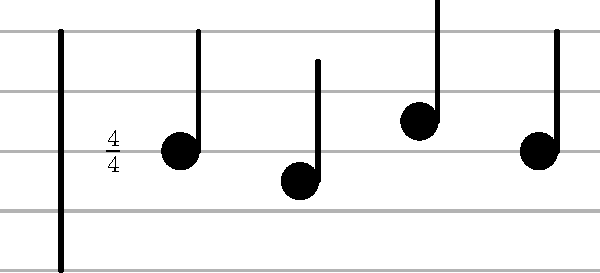How many beats are there in the given rhythm pattern? To determine the number of beats in this rhythm pattern, we need to follow these steps:

1. Identify the time signature: The time signature at the beginning of the staff is $\frac{4}{4}$. This means there are 4 beats per measure, and a quarter note gets one beat.

2. Count the notes: There are four notes in this pattern. Each note has a filled-in circular head with a stem, which represents a quarter note.

3. Determine the value of each note: In $\frac{4}{4}$ time, each quarter note is worth one beat.

4. Add up the beats: Since there are four quarter notes, and each is worth one beat, we add:
   1 + 1 + 1 + 1 = 4 beats

Therefore, the total number of beats in this rhythm pattern is 4.
Answer: 4 beats 